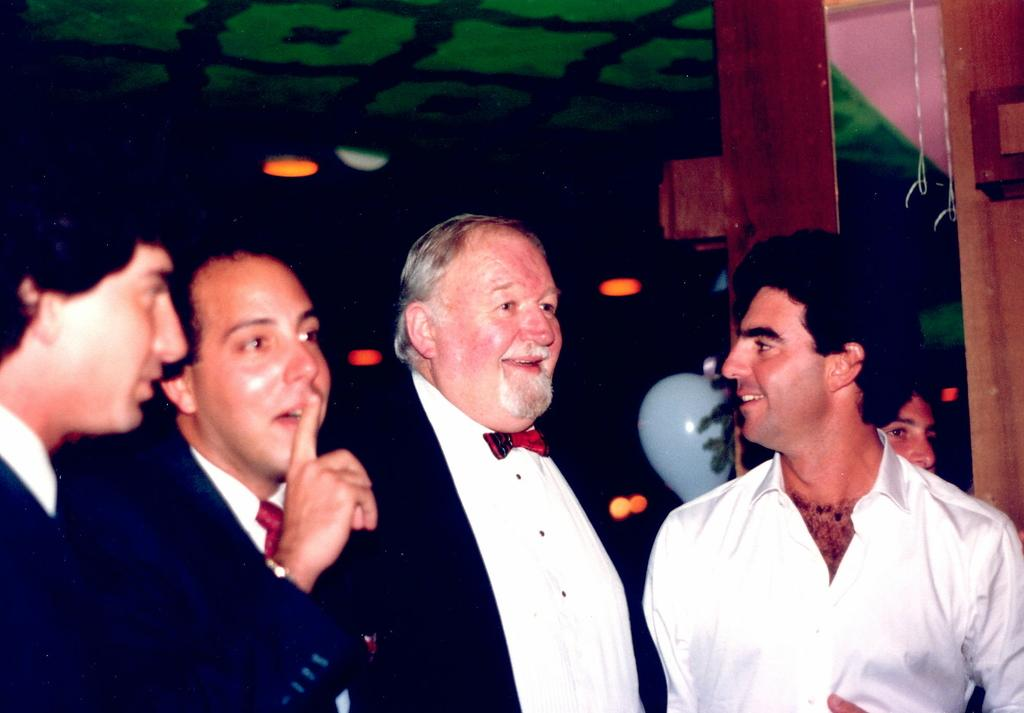What color is the ceiling in the room? The room has a green ceiling. How many lights are present in the room? There are multiple lights in the room. What can be found on the surface of the room? There are objects on the surface of the room. What type of material is visible in the room? There are threads visible in the room. Are there any people in the room? Yes, there are people standing in the room. What type of soda is being served in the room? There is no mention of soda or any beverage being served in the room. Can you compare the size of the hearts in the room? There is no mention of hearts in the room, so it is not possible to make a comparison. 